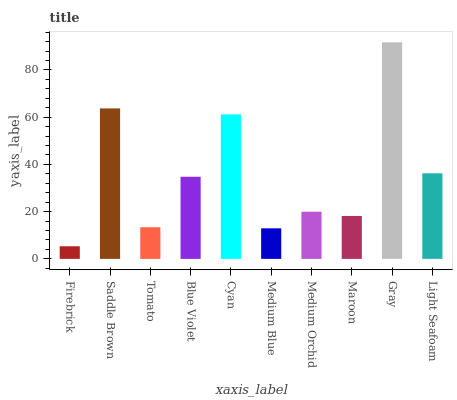Is Firebrick the minimum?
Answer yes or no. Yes. Is Gray the maximum?
Answer yes or no. Yes. Is Saddle Brown the minimum?
Answer yes or no. No. Is Saddle Brown the maximum?
Answer yes or no. No. Is Saddle Brown greater than Firebrick?
Answer yes or no. Yes. Is Firebrick less than Saddle Brown?
Answer yes or no. Yes. Is Firebrick greater than Saddle Brown?
Answer yes or no. No. Is Saddle Brown less than Firebrick?
Answer yes or no. No. Is Blue Violet the high median?
Answer yes or no. Yes. Is Medium Orchid the low median?
Answer yes or no. Yes. Is Light Seafoam the high median?
Answer yes or no. No. Is Tomato the low median?
Answer yes or no. No. 